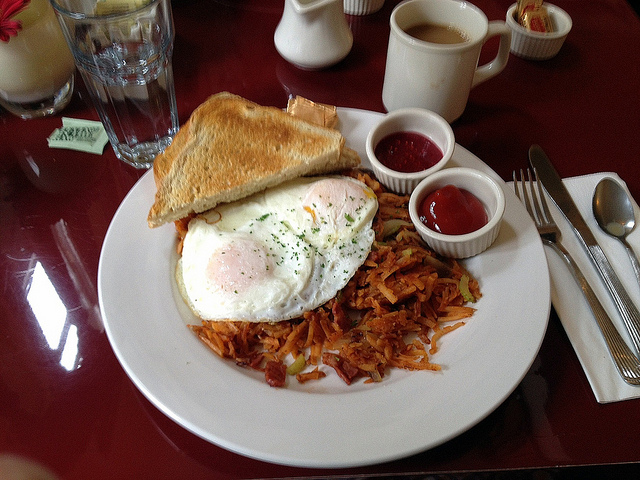What condiment is provided with the breakfast meal? The image shows two small containers of ketchup accompanying the breakfast plate, ideal for adding a juicy, slightly sweet lift to the eggs and hash browns. 